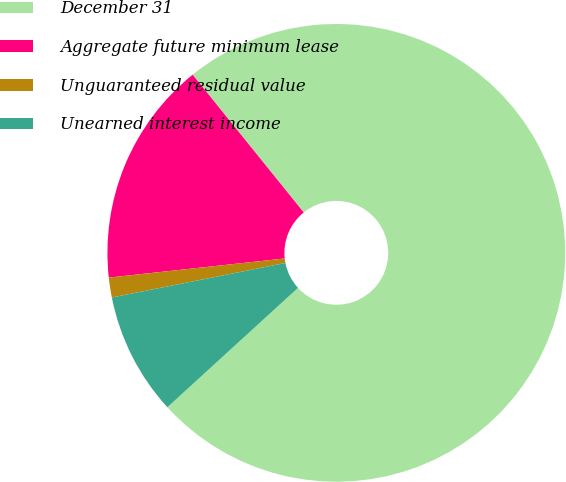<chart> <loc_0><loc_0><loc_500><loc_500><pie_chart><fcel>December 31<fcel>Aggregate future minimum lease<fcel>Unguaranteed residual value<fcel>Unearned interest income<nl><fcel>74.01%<fcel>15.92%<fcel>1.4%<fcel>8.66%<nl></chart> 